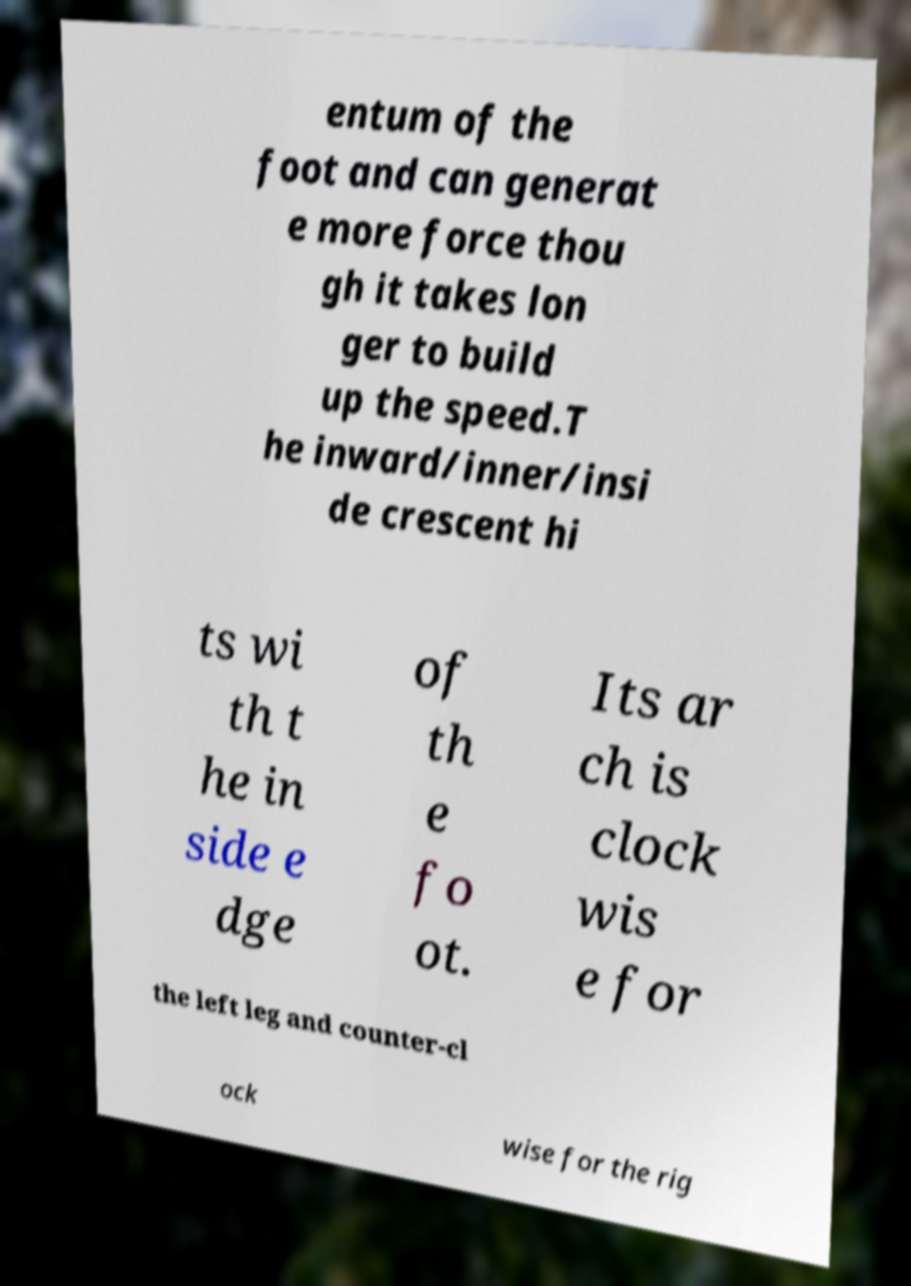Please read and relay the text visible in this image. What does it say? entum of the foot and can generat e more force thou gh it takes lon ger to build up the speed.T he inward/inner/insi de crescent hi ts wi th t he in side e dge of th e fo ot. Its ar ch is clock wis e for the left leg and counter-cl ock wise for the rig 